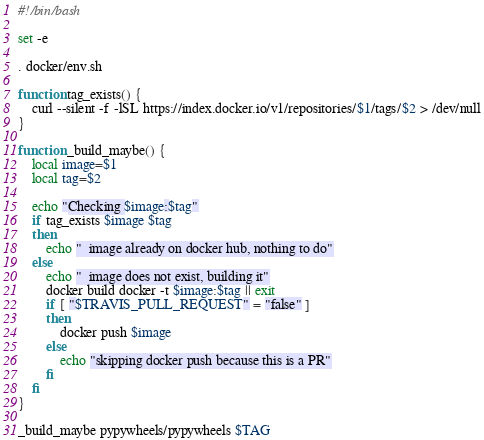<code> <loc_0><loc_0><loc_500><loc_500><_Bash_>#!/bin/bash

set -e

. docker/env.sh

function tag_exists() {
    curl --silent -f -lSL https://index.docker.io/v1/repositories/$1/tags/$2 > /dev/null
}

function _build_maybe() {
    local image=$1
    local tag=$2

    echo "Checking $image:$tag"
    if tag_exists $image $tag
    then
        echo "  image already on docker hub, nothing to do"
    else
        echo "  image does not exist, building it"
        docker build docker -t $image:$tag || exit
        if [ "$TRAVIS_PULL_REQUEST" = "false" ]
        then
            docker push $image
        else
            echo "skipping docker push because this is a PR"
        fi
    fi
}

_build_maybe pypywheels/pypywheels $TAG
</code> 